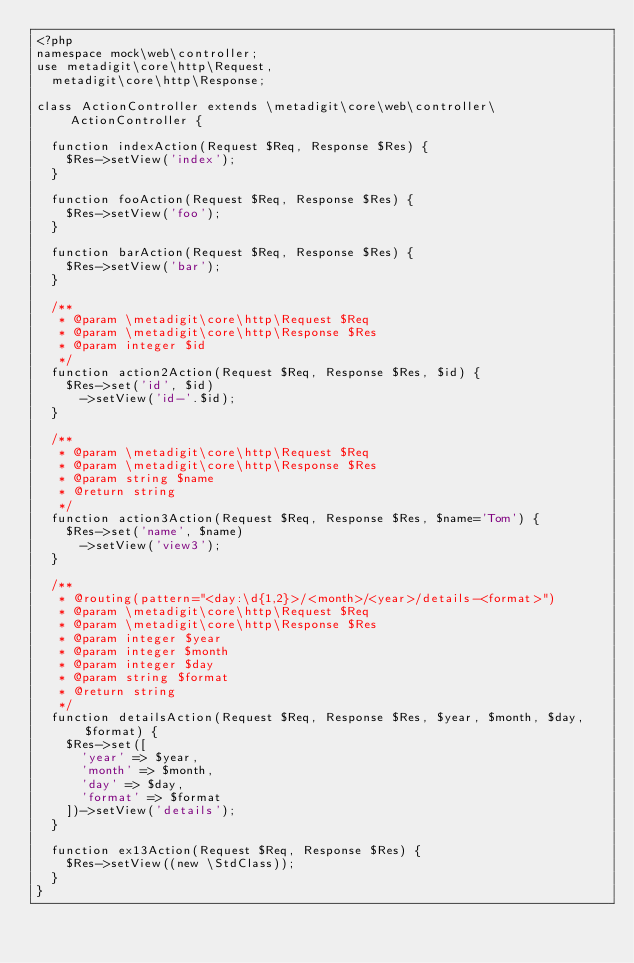Convert code to text. <code><loc_0><loc_0><loc_500><loc_500><_PHP_><?php
namespace mock\web\controller;
use metadigit\core\http\Request,
	metadigit\core\http\Response;

class ActionController extends \metadigit\core\web\controller\ActionController {

	function indexAction(Request $Req, Response $Res) {
		$Res->setView('index');
	}

	function fooAction(Request $Req, Response $Res) {
		$Res->setView('foo');
	}

	function barAction(Request $Req, Response $Res) {
		$Res->setView('bar');
	}

	/**
	 * @param \metadigit\core\http\Request $Req
	 * @param \metadigit\core\http\Response $Res
	 * @param integer $id
	 */
	function action2Action(Request $Req, Response $Res, $id) {
		$Res->set('id', $id)
			->setView('id-'.$id);
	}

	/**
	 * @param \metadigit\core\http\Request $Req
	 * @param \metadigit\core\http\Response $Res
	 * @param string $name
	 * @return string
	 */
	function action3Action(Request $Req, Response $Res, $name='Tom') {
		$Res->set('name', $name)
			->setView('view3');
	}

	/**
	 * @routing(pattern="<day:\d{1,2}>/<month>/<year>/details-<format>")
	 * @param \metadigit\core\http\Request $Req
	 * @param \metadigit\core\http\Response $Res
	 * @param integer $year
	 * @param integer $month
	 * @param integer $day
	 * @param string $format
	 * @return string
	 */
	function detailsAction(Request $Req, Response $Res, $year, $month, $day, $format) {
		$Res->set([
			'year' => $year,
			'month' => $month,
			'day' => $day,
			'format' => $format
		])->setView('details');
	}

	function ex13Action(Request $Req, Response $Res) {
		$Res->setView((new \StdClass));
	}
}</code> 